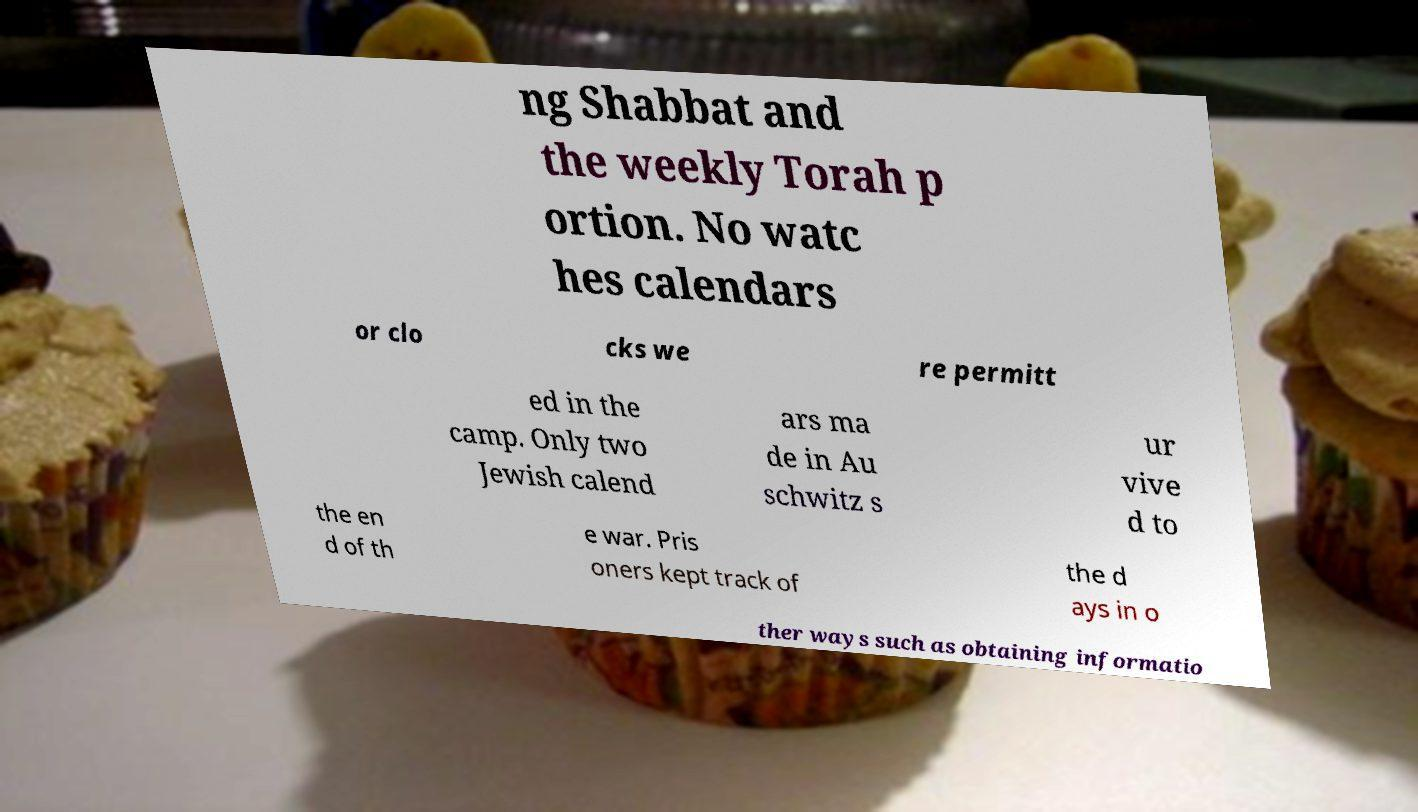Could you extract and type out the text from this image? ng Shabbat and the weekly Torah p ortion. No watc hes calendars or clo cks we re permitt ed in the camp. Only two Jewish calend ars ma de in Au schwitz s ur vive d to the en d of th e war. Pris oners kept track of the d ays in o ther ways such as obtaining informatio 